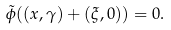Convert formula to latex. <formula><loc_0><loc_0><loc_500><loc_500>\tilde { \phi } ( ( x , \gamma ) + ( \xi , 0 ) ) = 0 .</formula> 